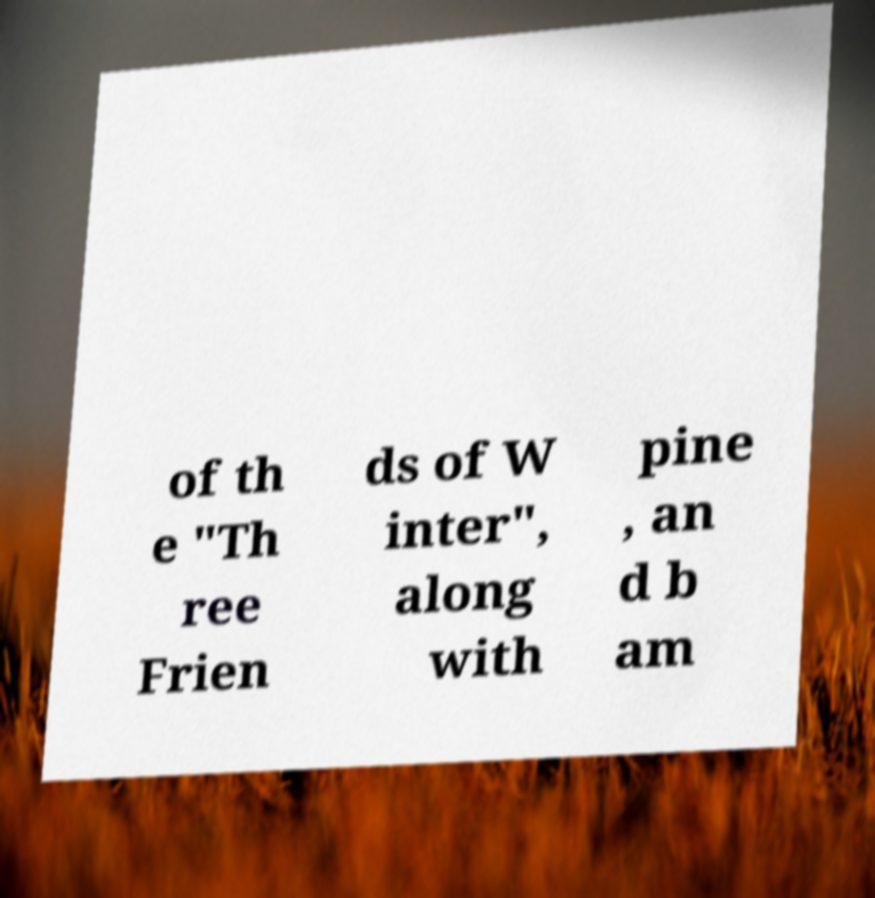Can you read and provide the text displayed in the image?This photo seems to have some interesting text. Can you extract and type it out for me? of th e "Th ree Frien ds of W inter", along with pine , an d b am 